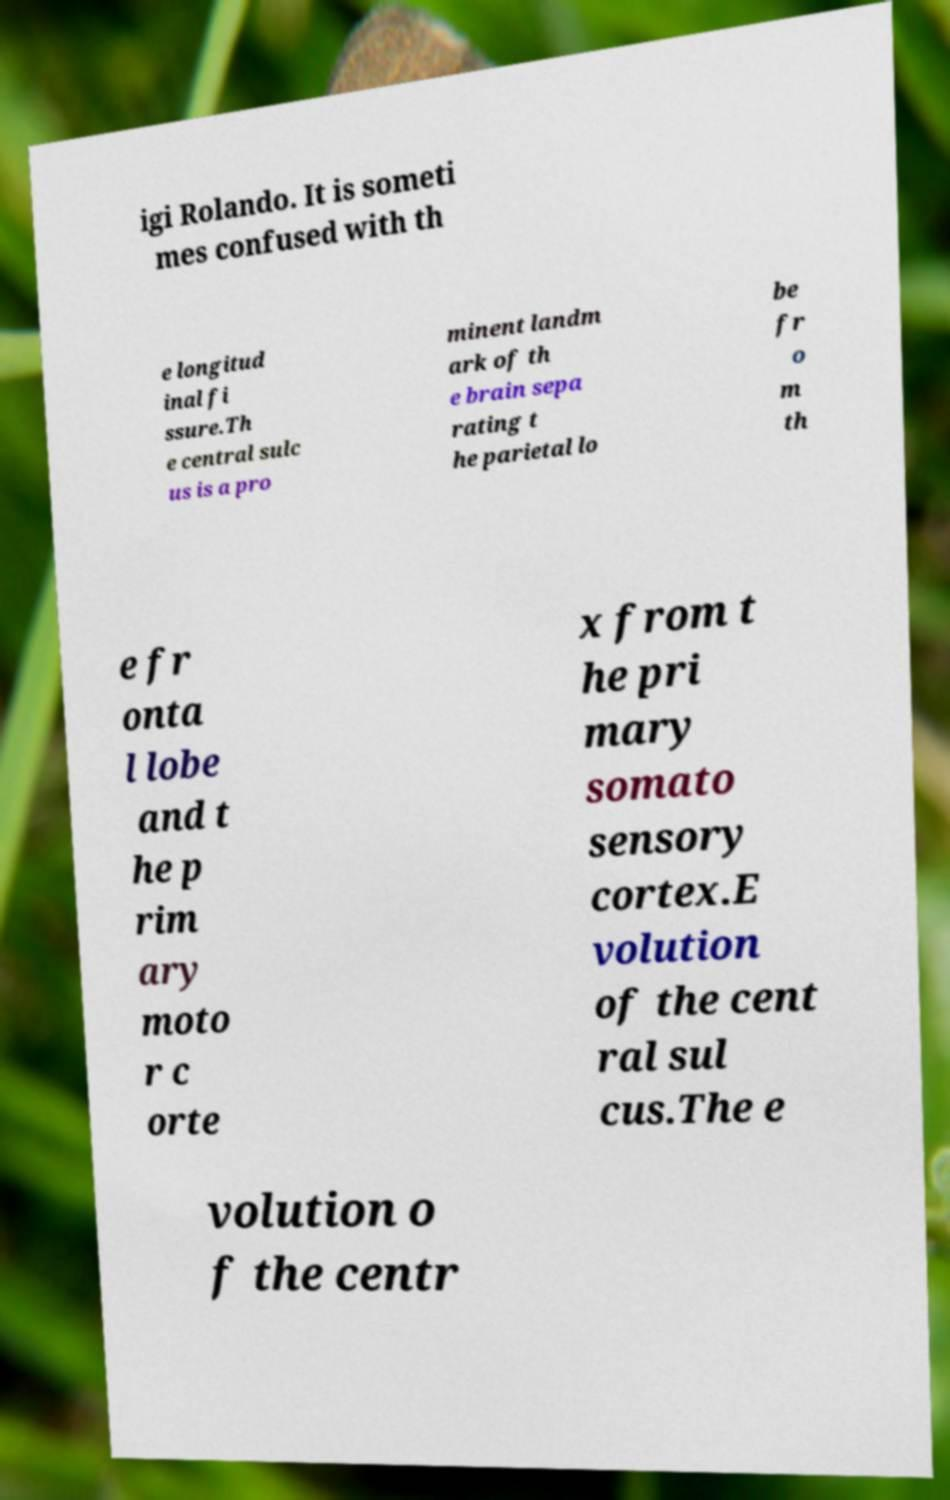Could you extract and type out the text from this image? igi Rolando. It is someti mes confused with th e longitud inal fi ssure.Th e central sulc us is a pro minent landm ark of th e brain sepa rating t he parietal lo be fr o m th e fr onta l lobe and t he p rim ary moto r c orte x from t he pri mary somato sensory cortex.E volution of the cent ral sul cus.The e volution o f the centr 